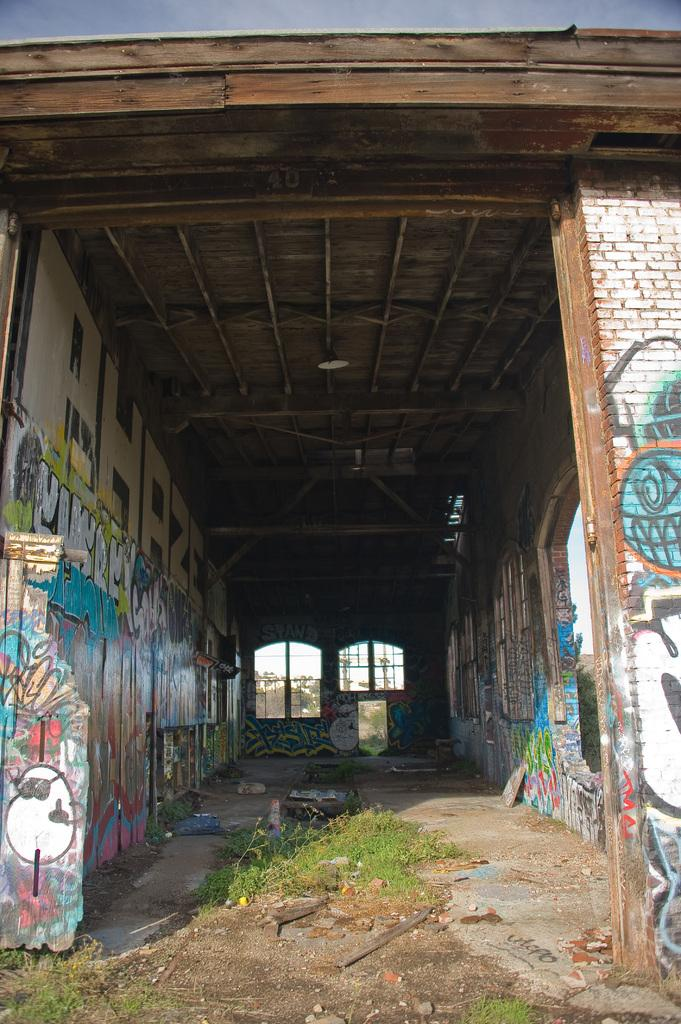What type of structure can be seen in the image? There is a wall in the image. What type of vegetation is present in the image? There is grass in the image. What type of decorations are visible in the image? There are banners in the image. What type of openings can be seen in the wall? There are windows in the image. How many cannons are visible in the image? There are no cannons present in the image. What type of shoe can be seen on the grass in the image? There is no shoe present in the image. 